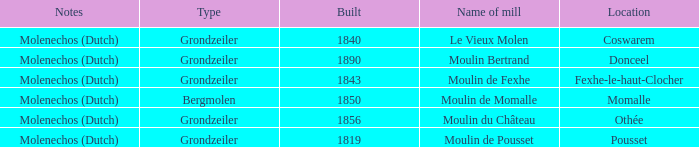Can you give me this table as a dict? {'header': ['Notes', 'Type', 'Built', 'Name of mill', 'Location'], 'rows': [['Molenechos (Dutch)', 'Grondzeiler', '1840', 'Le Vieux Molen', 'Coswarem'], ['Molenechos (Dutch)', 'Grondzeiler', '1890', 'Moulin Bertrand', 'Donceel'], ['Molenechos (Dutch)', 'Grondzeiler', '1843', 'Moulin de Fexhe', 'Fexhe-le-haut-Clocher'], ['Molenechos (Dutch)', 'Bergmolen', '1850', 'Moulin de Momalle', 'Momalle'], ['Molenechos (Dutch)', 'Grondzeiler', '1856', 'Moulin du Château', 'Othée'], ['Molenechos (Dutch)', 'Grondzeiler', '1819', 'Moulin de Pousset', 'Pousset']]} What is the Location of the Moulin Bertrand Mill? Donceel. 